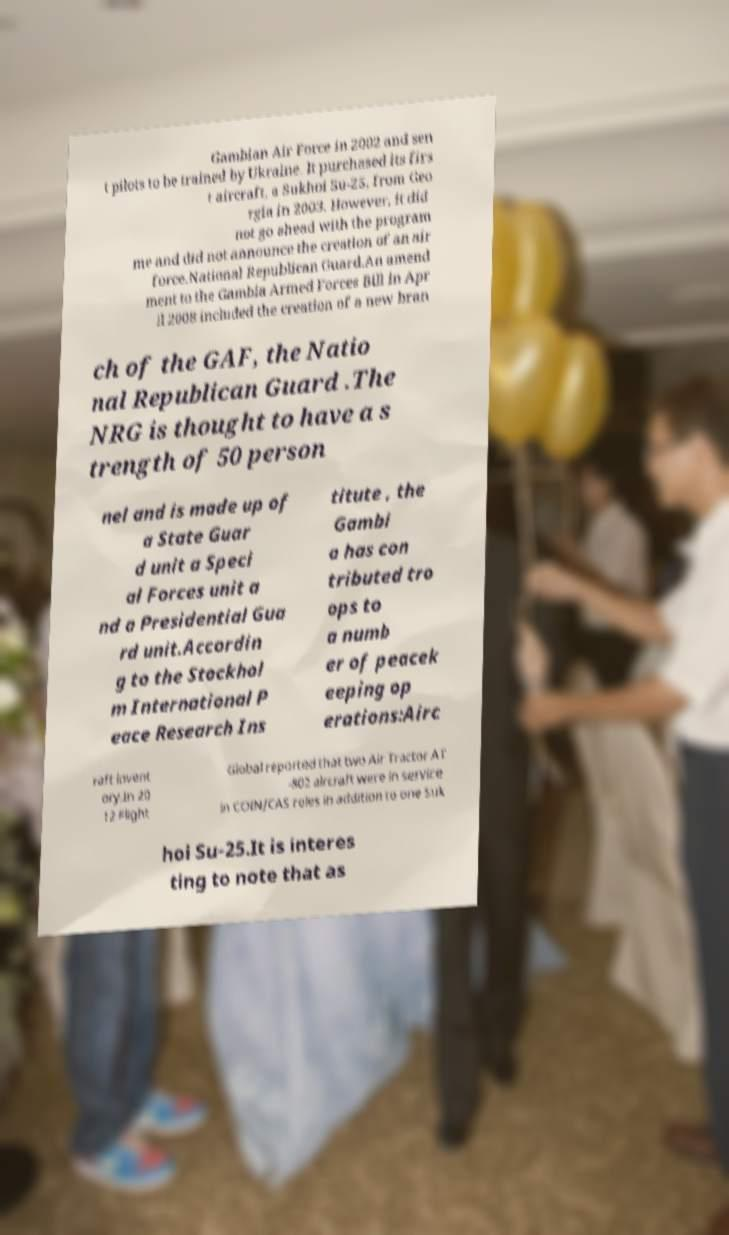Could you assist in decoding the text presented in this image and type it out clearly? Gambian Air Force in 2002 and sen t pilots to be trained by Ukraine. It purchased its firs t aircraft, a Sukhoi Su-25, from Geo rgia in 2003. However, it did not go ahead with the program me and did not announce the creation of an air force.National Republican Guard.An amend ment to the Gambia Armed Forces Bill in Apr il 2008 included the creation of a new bran ch of the GAF, the Natio nal Republican Guard .The NRG is thought to have a s trength of 50 person nel and is made up of a State Guar d unit a Speci al Forces unit a nd a Presidential Gua rd unit.Accordin g to the Stockhol m International P eace Research Ins titute , the Gambi a has con tributed tro ops to a numb er of peacek eeping op erations:Airc raft invent ory.In 20 12 Flight Global reported that two Air Tractor AT -802 aircraft were in service in COIN/CAS roles in addition to one Suk hoi Su-25.It is interes ting to note that as 